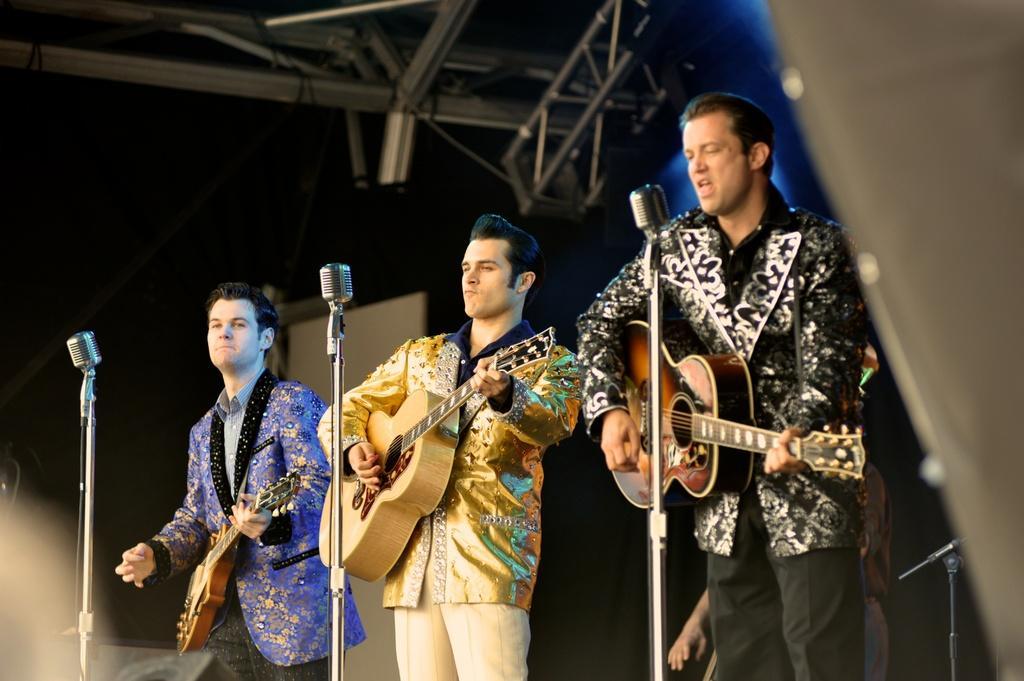In one or two sentences, can you explain what this image depicts? In this image I can see there are three men who are playing guitar in front of the microphone. 